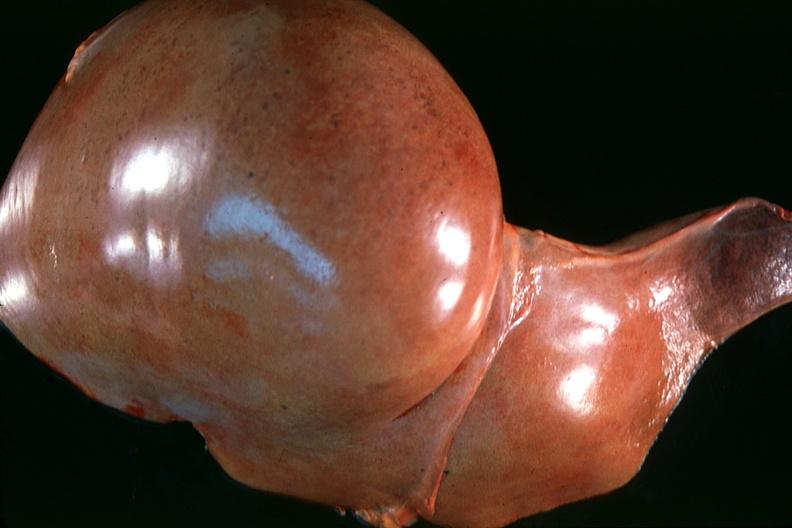what is present?
Answer the question using a single word or phrase. Hepatobiliary 